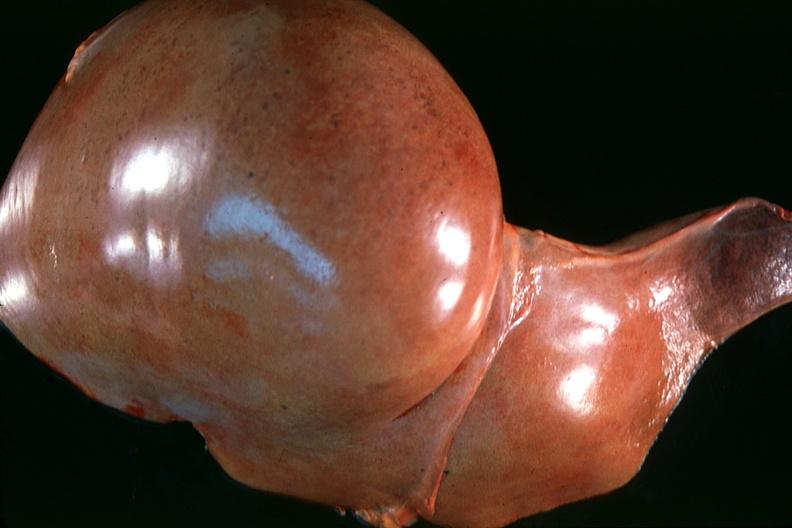what is present?
Answer the question using a single word or phrase. Hepatobiliary 